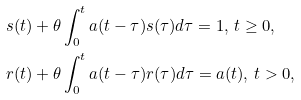<formula> <loc_0><loc_0><loc_500><loc_500>& s ( t ) + \theta \int _ { 0 } ^ { t } a ( t - \tau ) s ( \tau ) d \tau = 1 , \, t \geq 0 , \\ & r ( t ) + \theta \int _ { 0 } ^ { t } a ( t - \tau ) r ( \tau ) d \tau = a ( t ) , \, t > 0 ,</formula> 